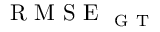<formula> <loc_0><loc_0><loc_500><loc_500>R M S E _ { G T }</formula> 